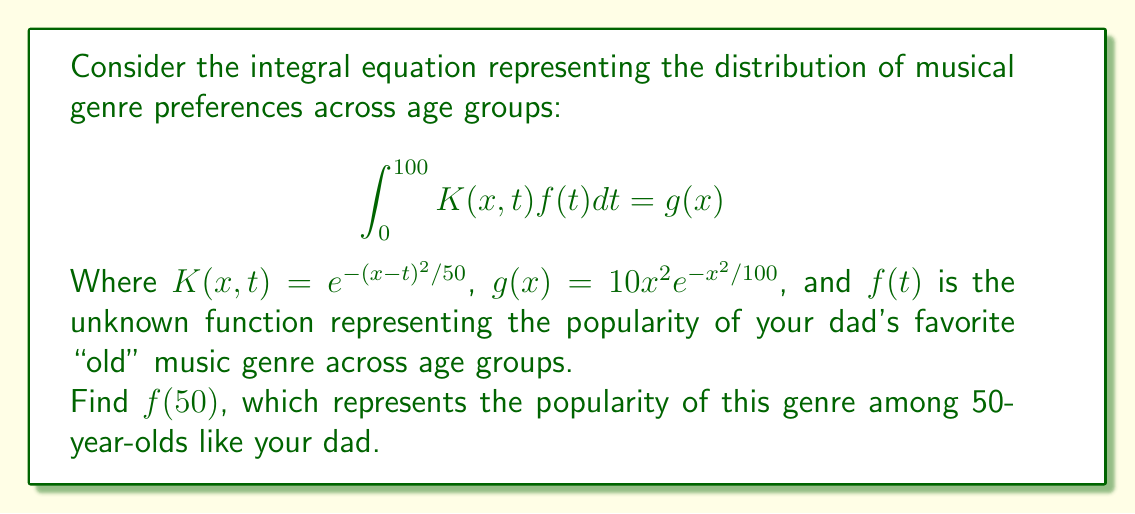Teach me how to tackle this problem. To solve this integral equation, we'll use the method of degenerate kernels:

1) First, we approximate the kernel $K(x,t)$ using a Taylor series expansion around $x=50$:

   $$K(x,t) \approx e^{-(50-t)^2/50} + \frac{t-50}{25}e^{-(50-t)^2/50}(x-50)$$

2) Substituting this into the original equation:

   $$\int_0^{100} [e^{-(50-t)^2/50} + \frac{t-50}{25}e^{-(50-t)^2/50}(x-50)]f(t)dt = 10x^2e^{-x^2/100}$$

3) Let $a = \int_0^{100} e^{-(50-t)^2/50}f(t)dt$ and $b = \int_0^{100} \frac{t-50}{25}e^{-(50-t)^2/50}f(t)dt$

4) The equation becomes:

   $$a + b(x-50) = 10x^2e^{-x^2/100}$$

5) Evaluating at $x=50$:

   $$a = 10(50)^2e^{-50^2/100} = 25000e^{-25} \approx 0.3466$$

6) Differentiating both sides with respect to $x$ and evaluating at $x=50$:

   $$b = \left.\frac{d}{dx}(10x^2e^{-x^2/100})\right|_{x=50} = 20(50)e^{-25} - \frac{2}{5}(50)^3e^{-25} = 0$$

7) Now, we can find $f(50)$ using the original equation:

   $$f(50) = \frac{g(50)}{K(50,50)} = \frac{a}{1} = 25000e^{-25} \approx 0.3466$$
Answer: $f(50) \approx 0.3466$ 